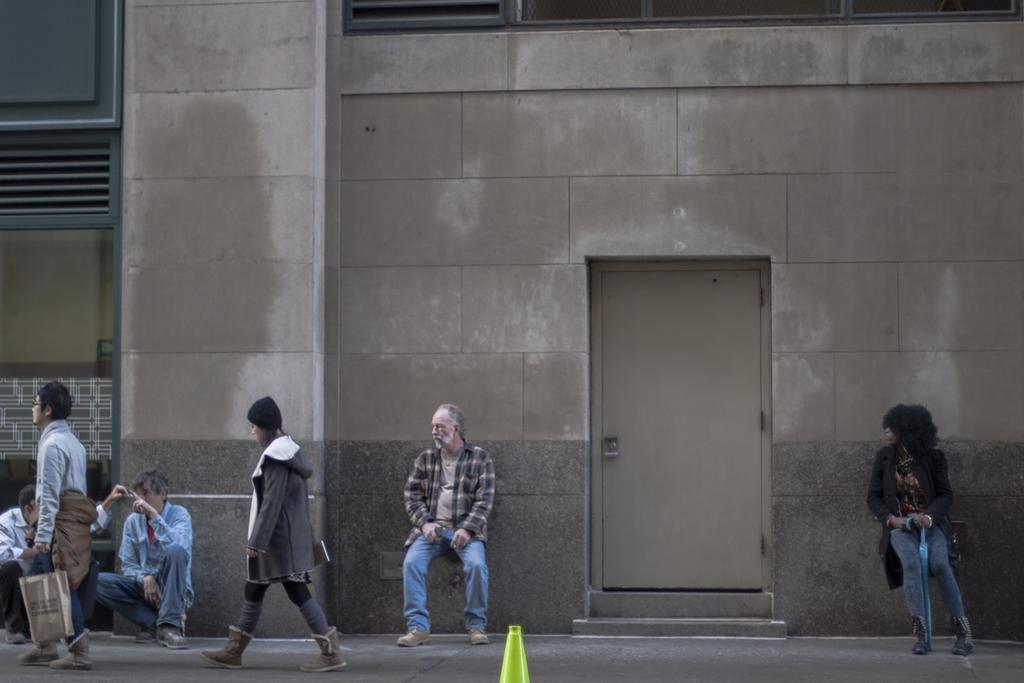Could you give a brief overview of what you see in this image? In this picture I can see there is a building, it has a door and there are few people walking here and some people are sitting here. 